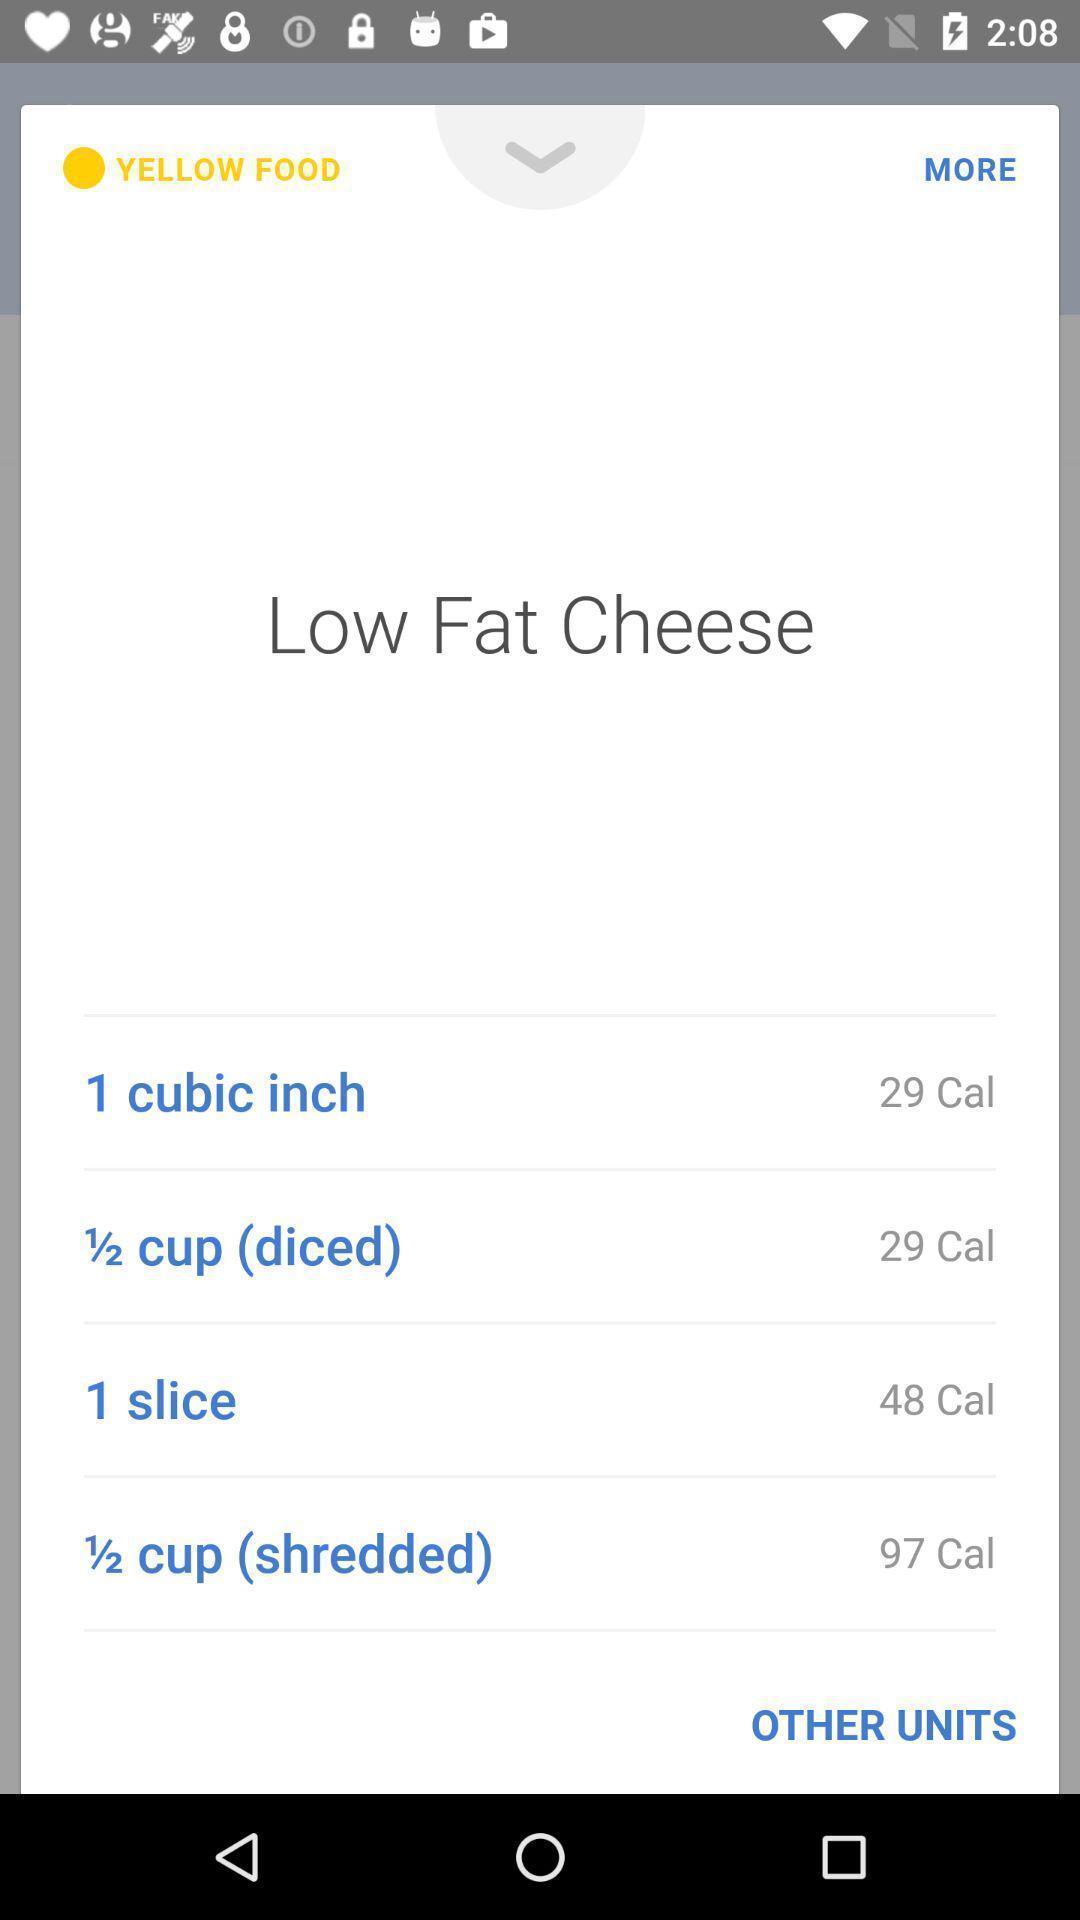Give me a narrative description of this picture. Page shows the low fat details on food app. 